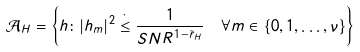<formula> <loc_0><loc_0><loc_500><loc_500>\mathcal { A } _ { H } & = \left \{ h \colon | h _ { m } | ^ { 2 } \stackrel { \cdot } { \leq } \frac { 1 } { S N R ^ { 1 - \tilde { r } _ { H } } } \quad \forall m \in \{ 0 , 1 , \dots , \nu \} \right \}</formula> 